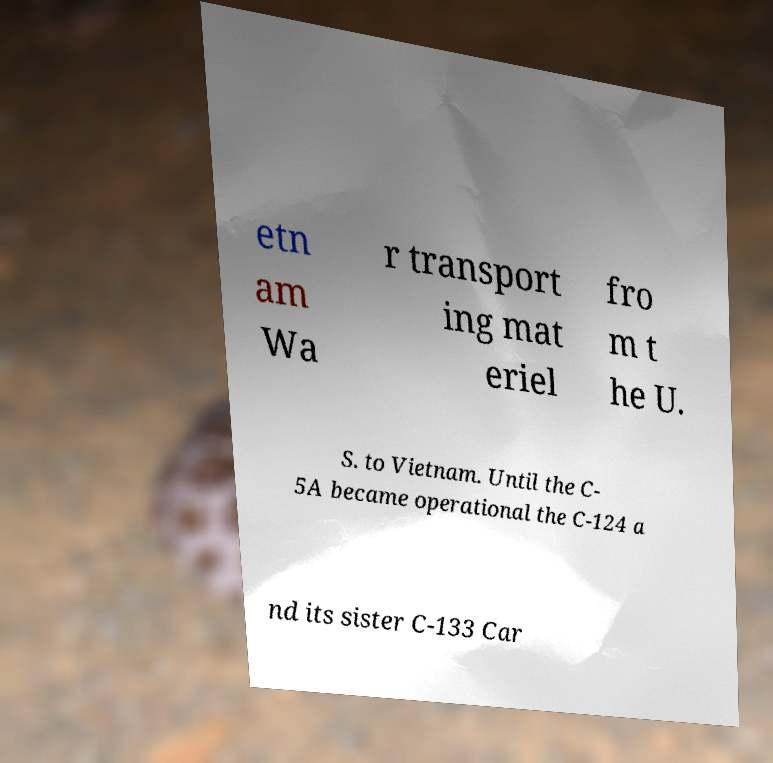For documentation purposes, I need the text within this image transcribed. Could you provide that? etn am Wa r transport ing mat eriel fro m t he U. S. to Vietnam. Until the C- 5A became operational the C-124 a nd its sister C-133 Car 